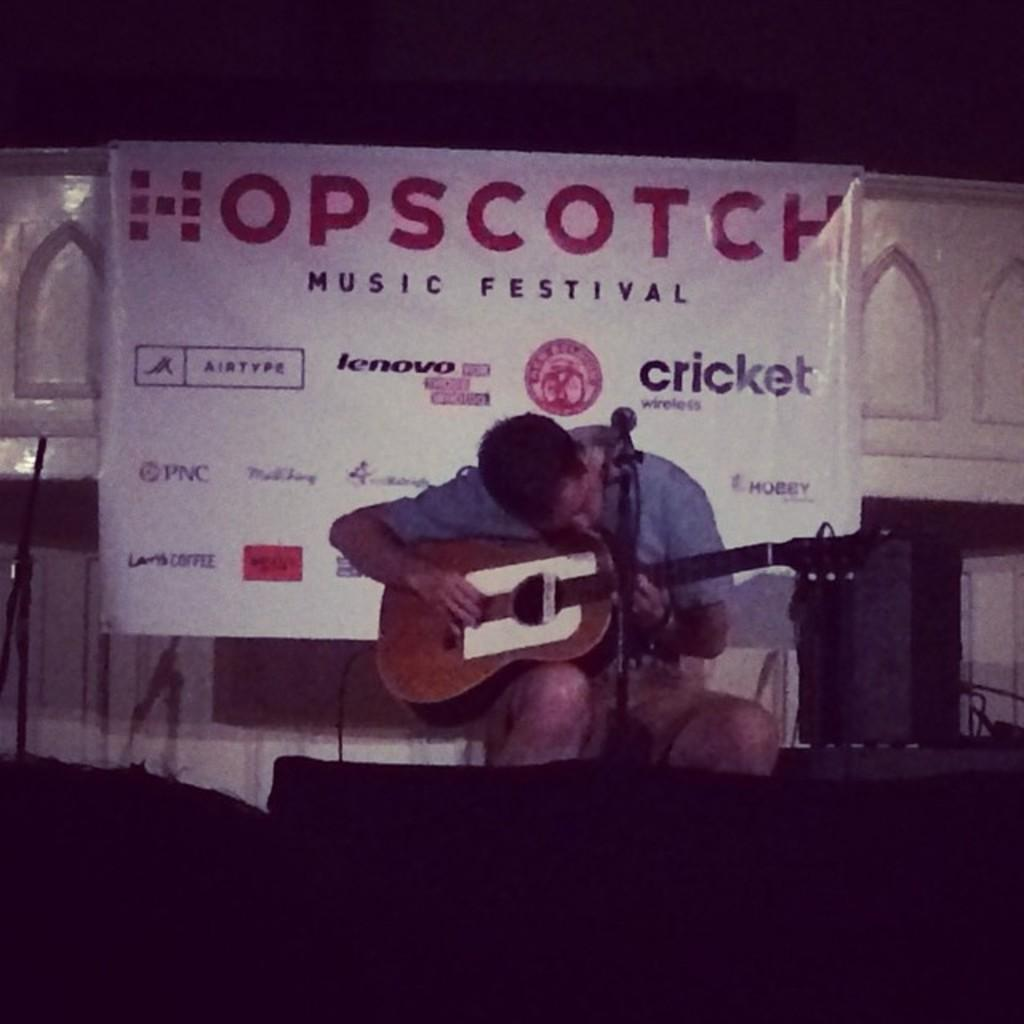What is the person in the image doing? The person is sitting in the image. What object is the person holding? The person is holding a guitar. What is the person positioned near in the image? The person is in front of a microphone. What can be seen in the background of the image? There is a banner in the background of the image. What type of rake is the person using in the image? There is no rake present in the image; the person is holding a guitar and standing in front of a microphone. How many letters are visible on the banner in the image? The number of letters on the banner cannot be determined from the image alone, as the text is not legible. 